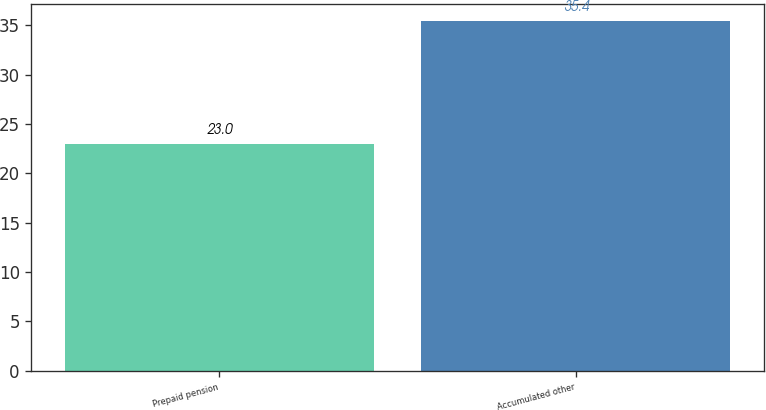Convert chart. <chart><loc_0><loc_0><loc_500><loc_500><bar_chart><fcel>Prepaid pension<fcel>Accumulated other<nl><fcel>23<fcel>35.4<nl></chart> 